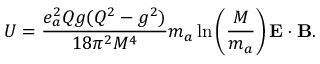Convert formula to latex. <formula><loc_0><loc_0><loc_500><loc_500>U = \frac { e _ { a } ^ { 2 } Q g ( Q ^ { 2 } - g ^ { 2 } ) } { 1 8 \pi ^ { 2 } M ^ { 4 } } m _ { a } \ln \left ( \frac { M } { m _ { a } } \right ) { E } \cdot { B } .</formula> 